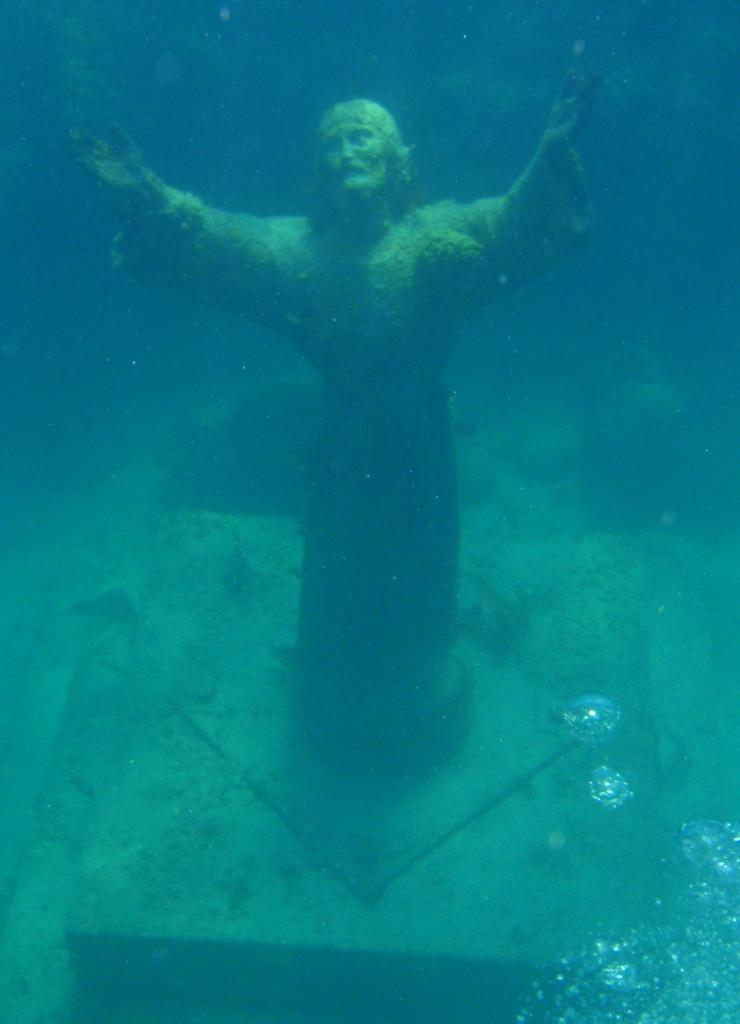What is located in the water in the image? There is a statue in the water. What can be seen in the bottom right corner of the image? Water bubbles are visible in the bottom right corner of the image. How many legs can be seen on the statue in the image? The image does not show the statue's legs, as it is partially submerged in the water. 